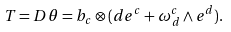<formula> <loc_0><loc_0><loc_500><loc_500>T = D \theta = b _ { c } \otimes ( d e ^ { c } + \omega ^ { c } _ { \, d } \wedge e ^ { d } ) .</formula> 